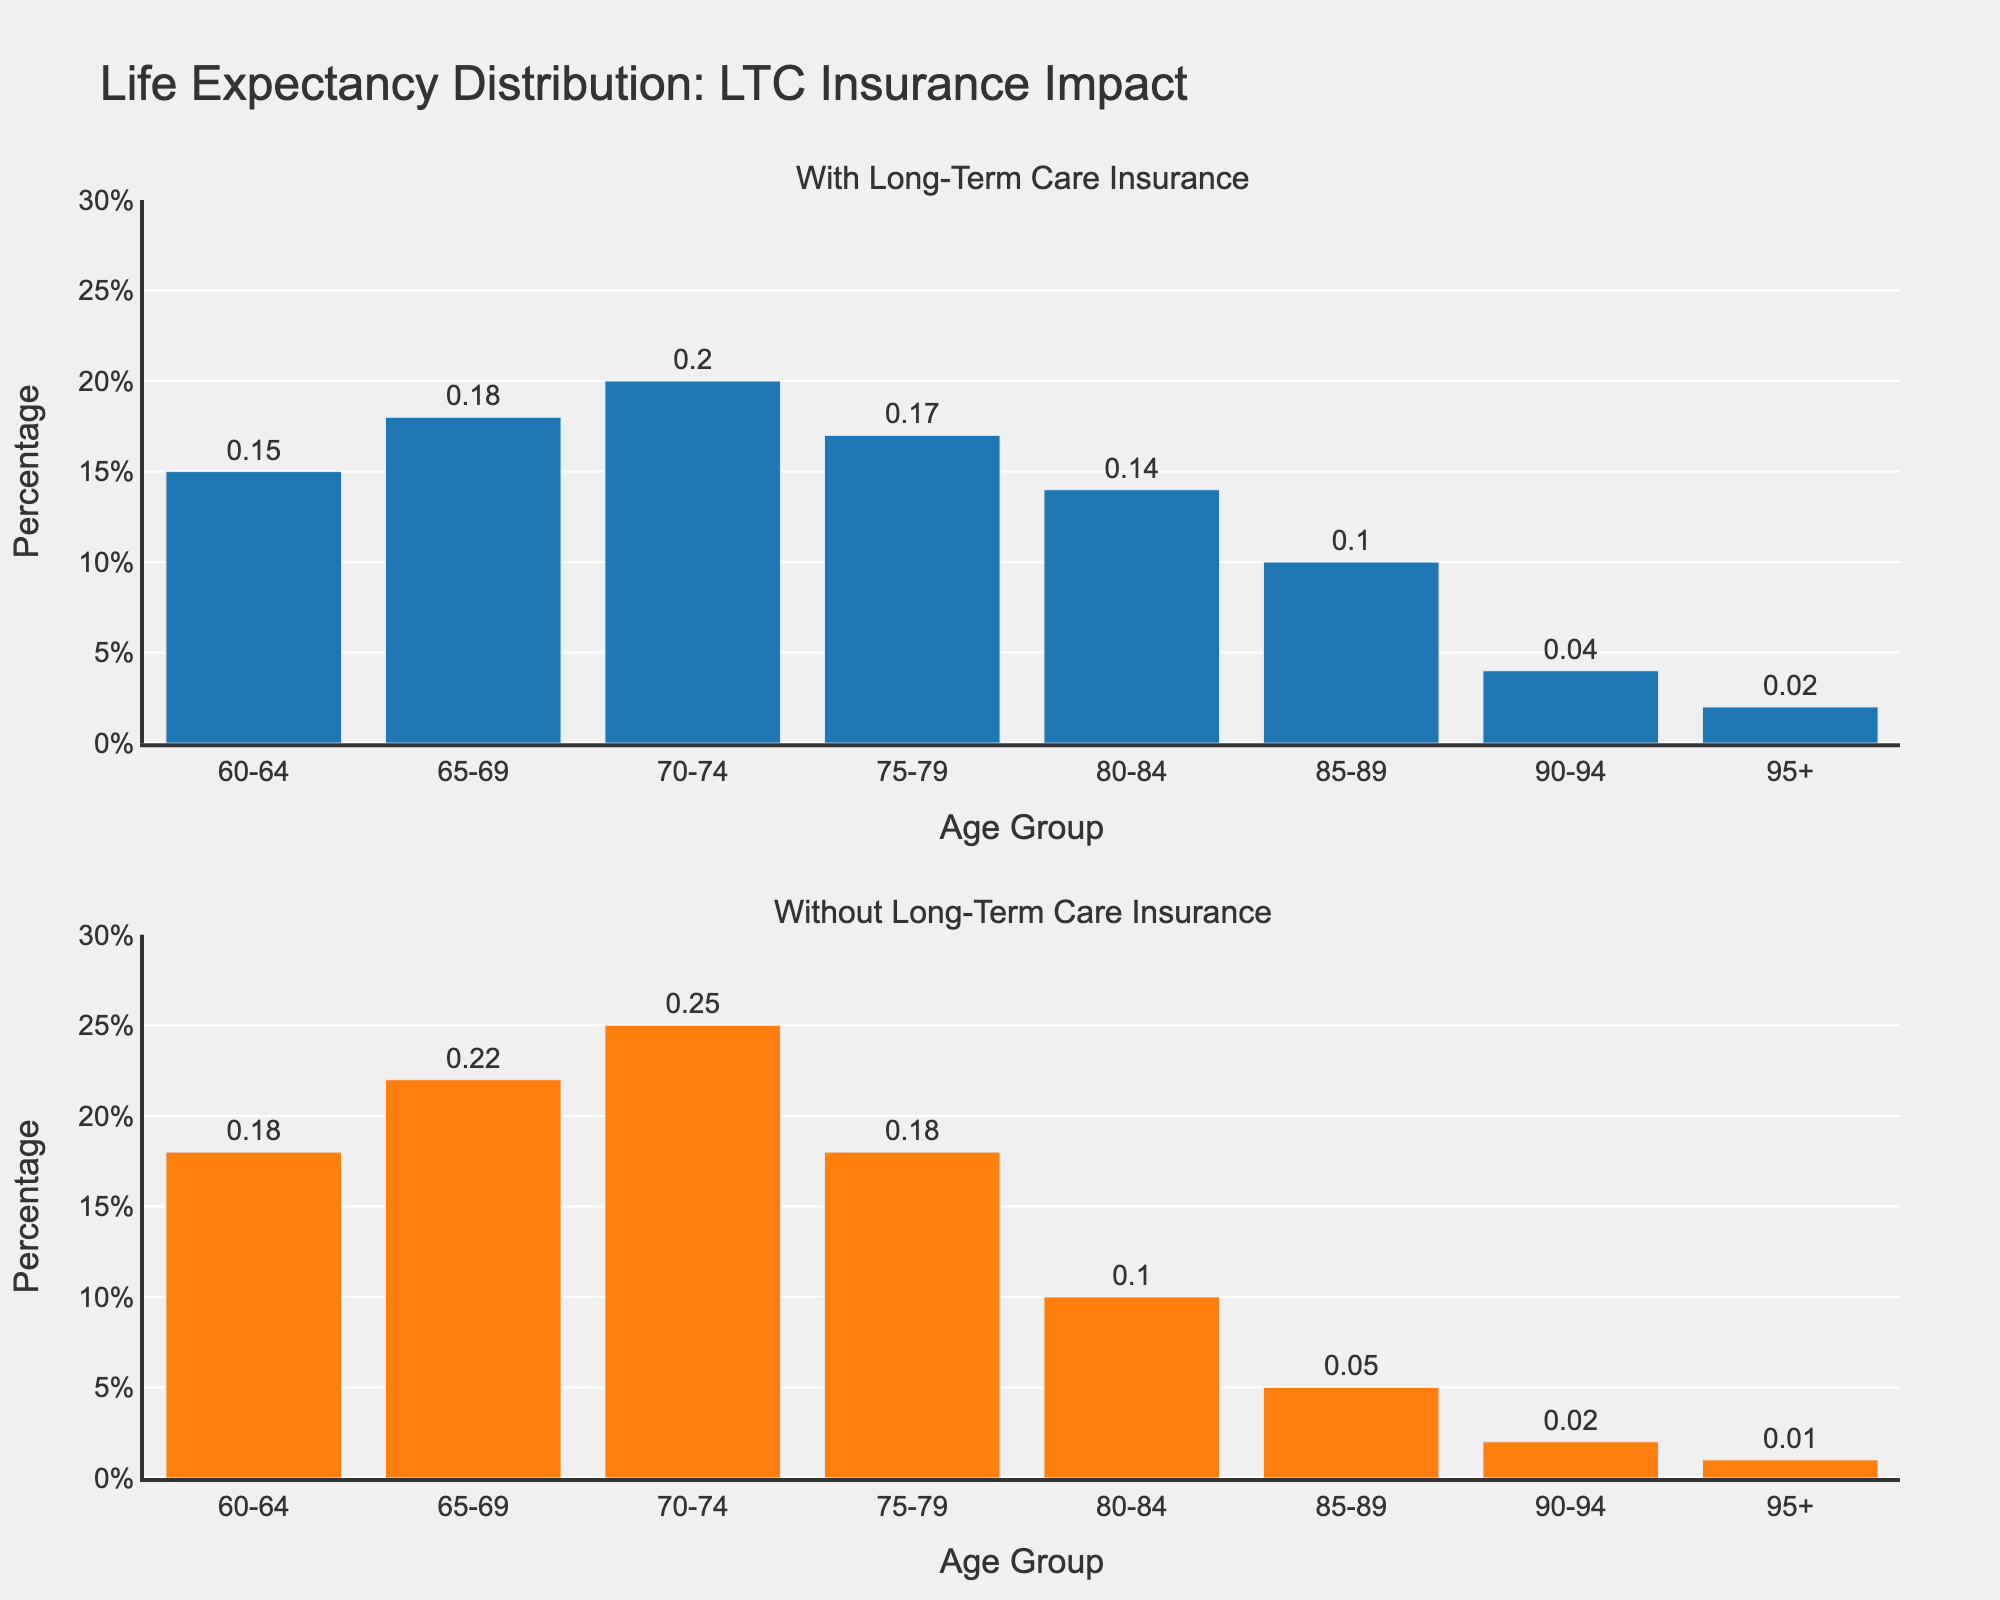Which age group has the highest percentage of individuals with long-term care insurance? In the first subplot, look for the bar with the tallest height. This is the age group 70-74, reaching 20%.
Answer: Age group 70-74 Which age group has the lowest percentage of individuals without long-term care insurance? In the second subplot, identify the bar with the smallest height. This is the age group 95+, which has a percentage of 1%.
Answer: Age group 95+ What is the difference in percentage between age group 70-74 with and without long-term care insurance? In the first subplot, age group 70-74 has a percentage of 20%. In the second subplot, the same age group has a percentage of 25%. The difference is 25% - 20% = 5%.
Answer: 5% How does the percentage of individuals with long-term care insurance change from age group 75-79 to 80-84? In the first subplot, compare the bar heights for age groups 75-79 (17%) and 80-84 (14%). The change is calculated as 17% - 14% = 3%.
Answer: Decreases by 3% What is the average percentage of individuals with long-term care insurance for age groups 60-64 and 65-69? In the first subplot, sum the percentages for age groups 60-64 (15%) and 65-69 (18%) and divide by 2. (15% + 18%) / 2 = 16.5%.
Answer: 16.5% Which age group shows a greater percentage of individuals without long-term care insurance compared to those with it? Compare both subplots for each age group and identify which group has a higher percentage in the second subplot. Age group 70-74 shows a higher percentage without long-term care insurance (25%) compared to with it (20%).
Answer: Age group 70-74 What is the range of percentages for individuals with and without long-term care insurance across all age groups? For individuals with long-term care insurance, the highest percentage is 20% (age group 70-74) and the lowest is 2% (age group 95+). Thus, the range is 20% - 2% = 18%. For individuals without long-term care insurance, the highest percentage is 25% (age group 70-74) and the lowest is 1% (age group 95+), so the range is 25% - 1% = 24%.
Answer: With LTC: 18%, Without LTC: 24% Which age groups have the same percentage of individuals both with and without long-term care insurance? Compare the heights of bars in both subplots for each age group. Age groups 75-79 both have a percentage of 18%.
Answer: Age group 75-79 What is the total percentage sum for age groups with long-term care insurance combined? In the first subplot, sum the percentages for all age groups: 15% + 18% + 20% + 17% + 14% + 10% + 4% + 2% = 100%.
Answer: 100% How much higher is the percentage of individuals without long-term care insurance in the 65-69 age group compared to those with it? In the first subplot, the percentage for age group 65-69 is 18%. In the second subplot, it's 22%. The difference is 22% - 18% = 4%.
Answer: 4% 